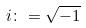<formula> <loc_0><loc_0><loc_500><loc_500>i \colon = \sqrt { - 1 }</formula> 